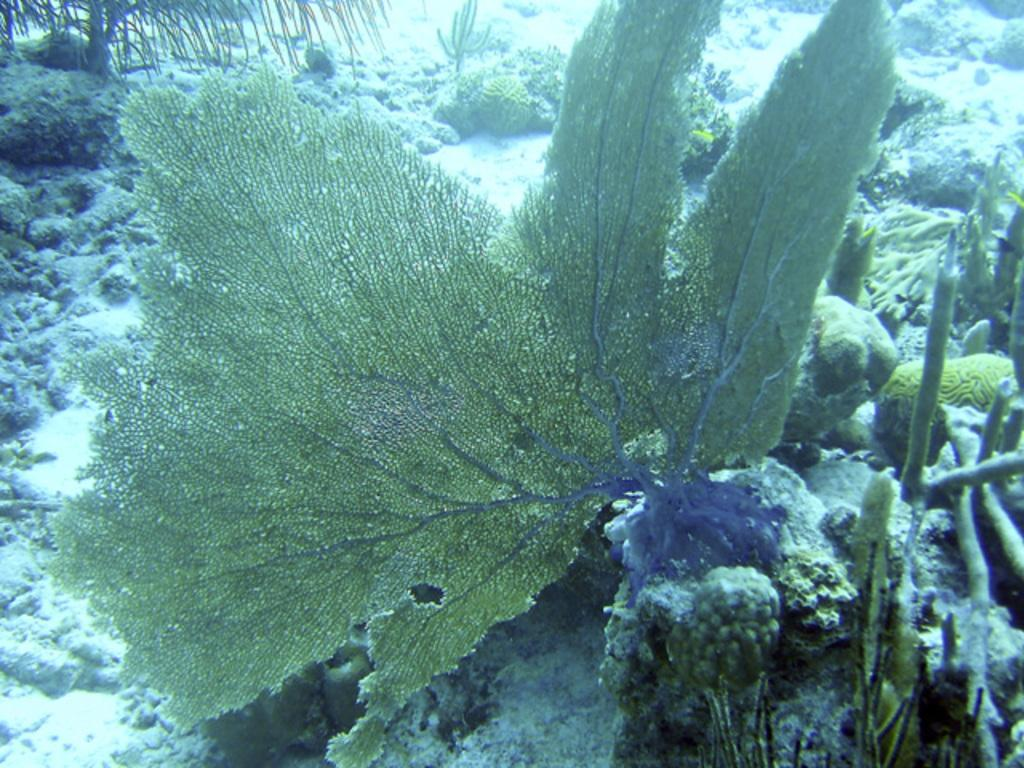What type of plants can be seen in the image? There are green color sea plants in the image. Can you describe the color of the sea plants? The sea plants are green in color. Where is the badge located in the image? There is no badge present in the image; it only features green color sea plants. 